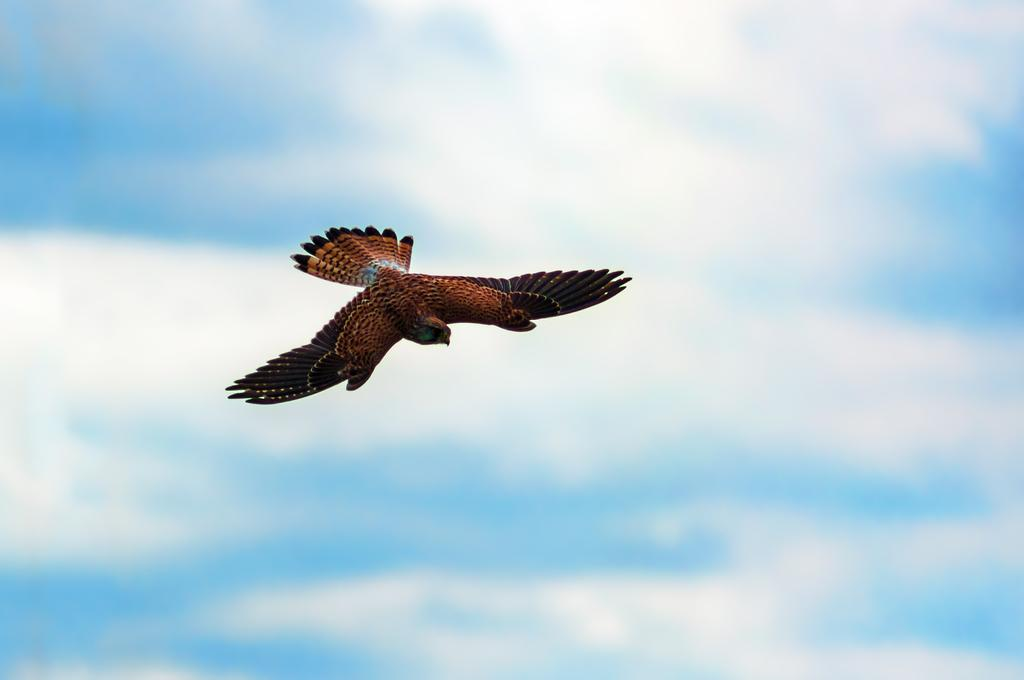What animal is the main subject of the image? There is an eagle in the image. What is the eagle doing in the image? The eagle is flying in the air. Can you describe the coloring of the eagle? The eagle has brown and black coloring. What can be seen in the background of the image? There is a sky visible in the background of the image. What is the condition of the sky in the image? There are clouds in the sky. What type of skin condition does the eagle have in the image? There is no indication of a skin condition on the eagle in the image. Is the eagle in jail in the image? There is no jail present in the image, and the eagle is flying freely in the air. 